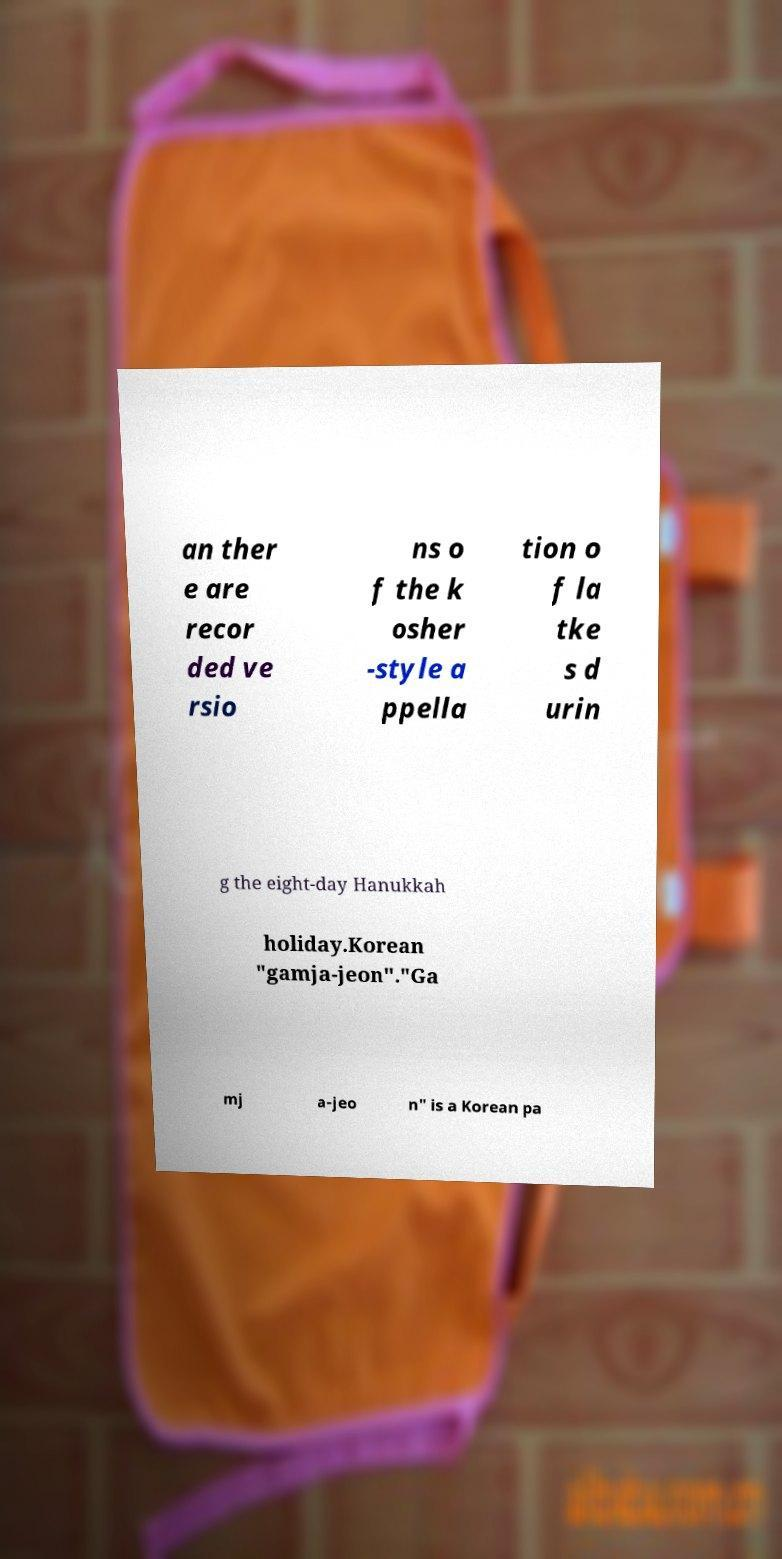For documentation purposes, I need the text within this image transcribed. Could you provide that? an ther e are recor ded ve rsio ns o f the k osher -style a ppella tion o f la tke s d urin g the eight-day Hanukkah holiday.Korean "gamja-jeon"."Ga mj a-jeo n" is a Korean pa 